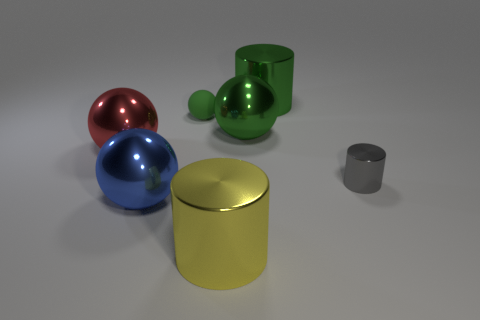Subtract all green cubes. How many green spheres are left? 2 Subtract 1 cylinders. How many cylinders are left? 2 Subtract all large spheres. How many spheres are left? 1 Subtract all red balls. How many balls are left? 3 Add 1 tiny shiny spheres. How many objects exist? 8 Subtract all spheres. How many objects are left? 3 Subtract all red spheres. Subtract all yellow cylinders. How many spheres are left? 3 Add 4 tiny cyan objects. How many tiny cyan objects exist? 4 Subtract 0 blue cubes. How many objects are left? 7 Subtract all green rubber objects. Subtract all gray metal things. How many objects are left? 5 